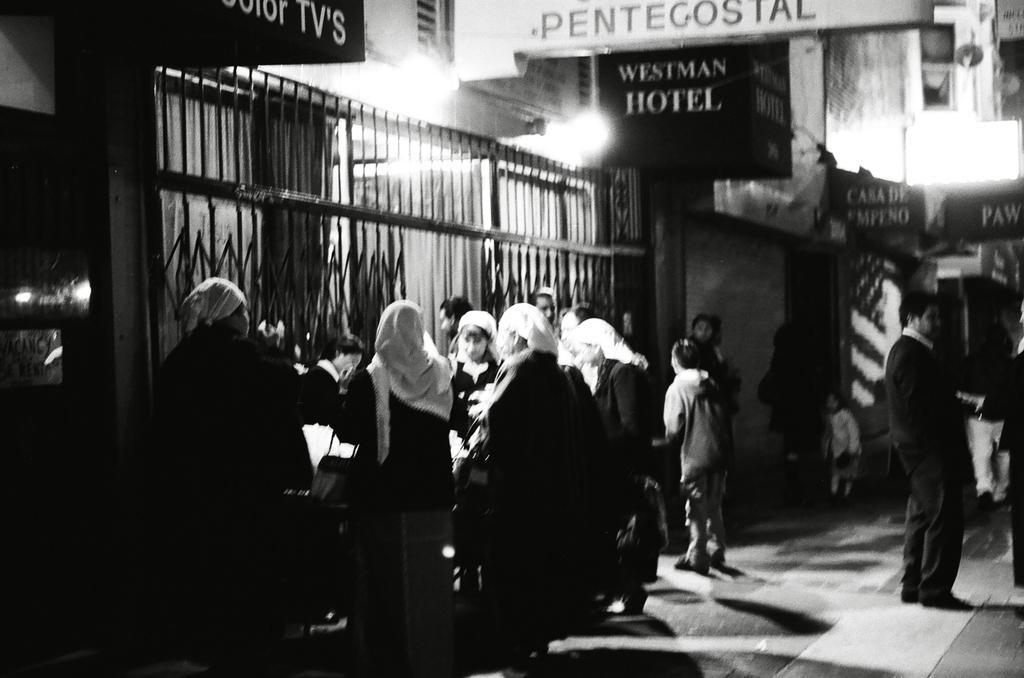Could you give a brief overview of what you see in this image? This image is a black and white image. This image is taken outdoors. At the bottom of the image there is a floor. In the background there are a few buildings with walls, windows and doors. There are many boards with text on them. There are a few iron bars. In the middle of the image many people are standing on the floor. On the right side of the image two persons are standing on the floor and a man is walking. 